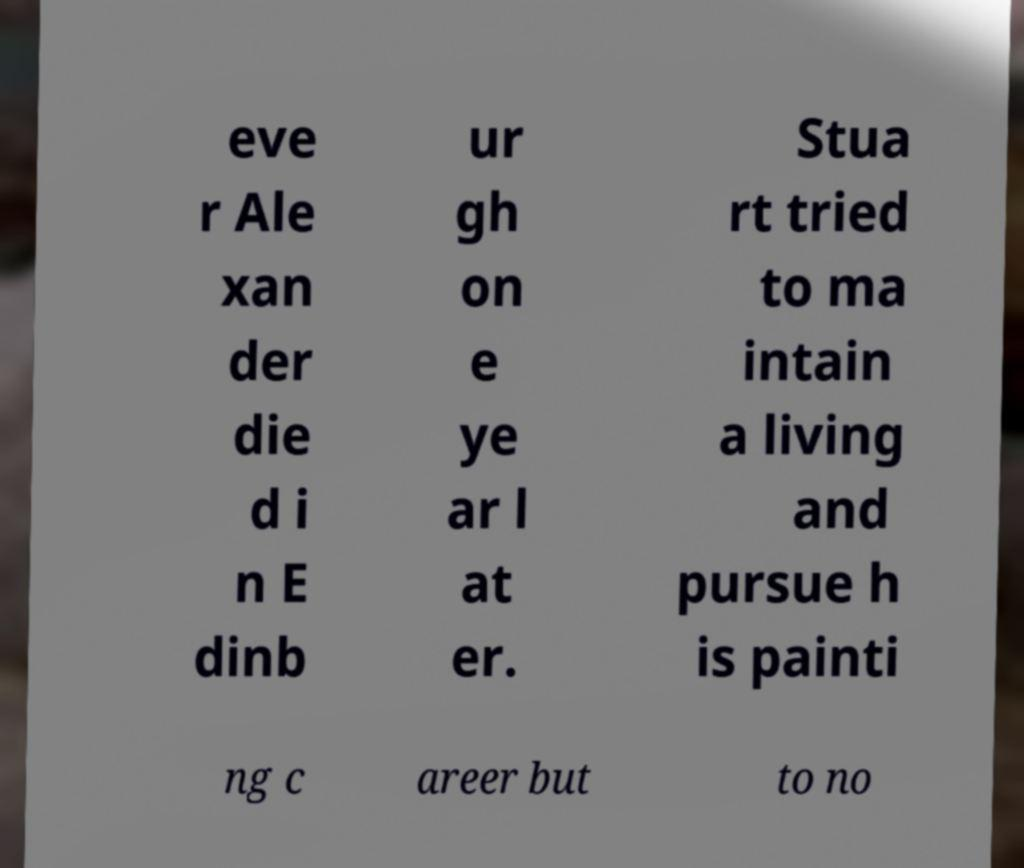Could you assist in decoding the text presented in this image and type it out clearly? eve r Ale xan der die d i n E dinb ur gh on e ye ar l at er. Stua rt tried to ma intain a living and pursue h is painti ng c areer but to no 